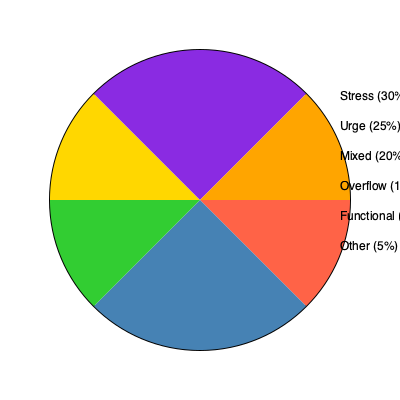The pie chart shows the prevalence of different types of incontinence among adults aged 65 and older. What percentage of incontinence cases in this age group are classified as either stress or urge incontinence? To solve this question, we need to follow these steps:

1. Identify the percentages for stress and urge incontinence from the pie chart:
   - Stress incontinence: 30%
   - Urge incontinence: 25%

2. Add these two percentages together:
   $30\% + 25\% = 55\%$

3. Convert the decimal to a percentage:
   $0.55 \times 100\% = 55\%$

Therefore, the combined percentage of stress and urge incontinence cases among adults aged 65 and older is 55%.
Answer: 55% 